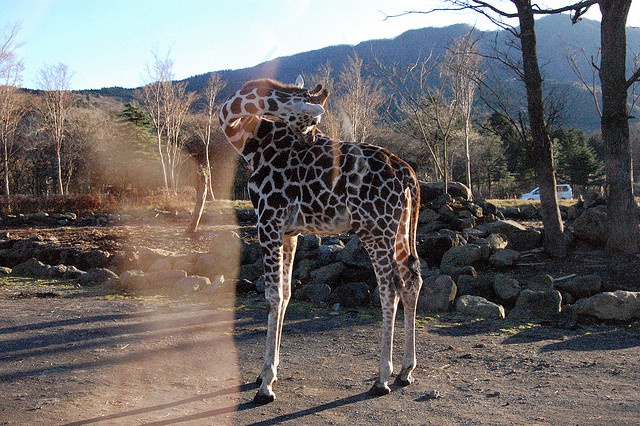Describe the objects in this image and their specific colors. I can see giraffe in lightblue, black, gray, and maroon tones and car in lightblue, gray, and darkgray tones in this image. 